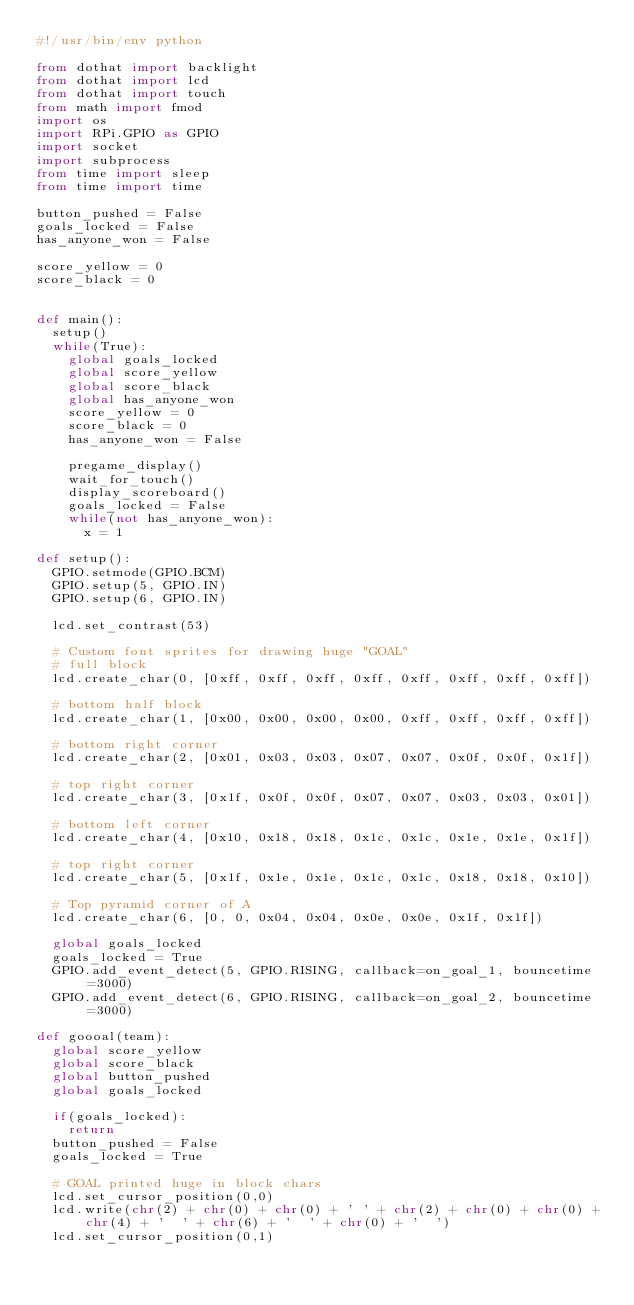<code> <loc_0><loc_0><loc_500><loc_500><_Python_>#!/usr/bin/env python

from dothat import backlight
from dothat import lcd
from dothat import touch
from math import fmod
import os
import RPi.GPIO as GPIO
import socket
import subprocess
from time import sleep
from time import time

button_pushed = False
goals_locked = False
has_anyone_won = False

score_yellow = 0
score_black = 0


def main():
  setup()
  while(True):
    global goals_locked
    global score_yellow
    global score_black
    global has_anyone_won
    score_yellow = 0
    score_black = 0
    has_anyone_won = False

    pregame_display()
    wait_for_touch()
    display_scoreboard()
    goals_locked = False
    while(not has_anyone_won):
      x = 1

def setup():
  GPIO.setmode(GPIO.BCM)
  GPIO.setup(5, GPIO.IN)
  GPIO.setup(6, GPIO.IN)

  lcd.set_contrast(53)

  # Custom font sprites for drawing huge "GOAL"
  # full block
  lcd.create_char(0, [0xff, 0xff, 0xff, 0xff, 0xff, 0xff, 0xff, 0xff])

  # bottom half block
  lcd.create_char(1, [0x00, 0x00, 0x00, 0x00, 0xff, 0xff, 0xff, 0xff])

  # bottom right corner
  lcd.create_char(2, [0x01, 0x03, 0x03, 0x07, 0x07, 0x0f, 0x0f, 0x1f])

  # top right corner
  lcd.create_char(3, [0x1f, 0x0f, 0x0f, 0x07, 0x07, 0x03, 0x03, 0x01])

  # bottom left corner
  lcd.create_char(4, [0x10, 0x18, 0x18, 0x1c, 0x1c, 0x1e, 0x1e, 0x1f])

  # top right corner
  lcd.create_char(5, [0x1f, 0x1e, 0x1e, 0x1c, 0x1c, 0x18, 0x18, 0x10])

  # Top pyramid corner of A
  lcd.create_char(6, [0, 0, 0x04, 0x04, 0x0e, 0x0e, 0x1f, 0x1f])
  
  global goals_locked 
  goals_locked = True
  GPIO.add_event_detect(5, GPIO.RISING, callback=on_goal_1, bouncetime=3000)
  GPIO.add_event_detect(6, GPIO.RISING, callback=on_goal_2, bouncetime=3000)

def goooal(team):
  global score_yellow
  global score_black
  global button_pushed
  global goals_locked

  if(goals_locked):
    return
  button_pushed = False
  goals_locked = True

  # GOAL printed huge in block chars
  lcd.set_cursor_position(0,0)
  lcd.write(chr(2) + chr(0) + chr(0) + ' ' + chr(2) + chr(0) + chr(0) + chr(4) + '  ' + chr(6) + '  ' + chr(0) + '  ')
  lcd.set_cursor_position(0,1)</code> 